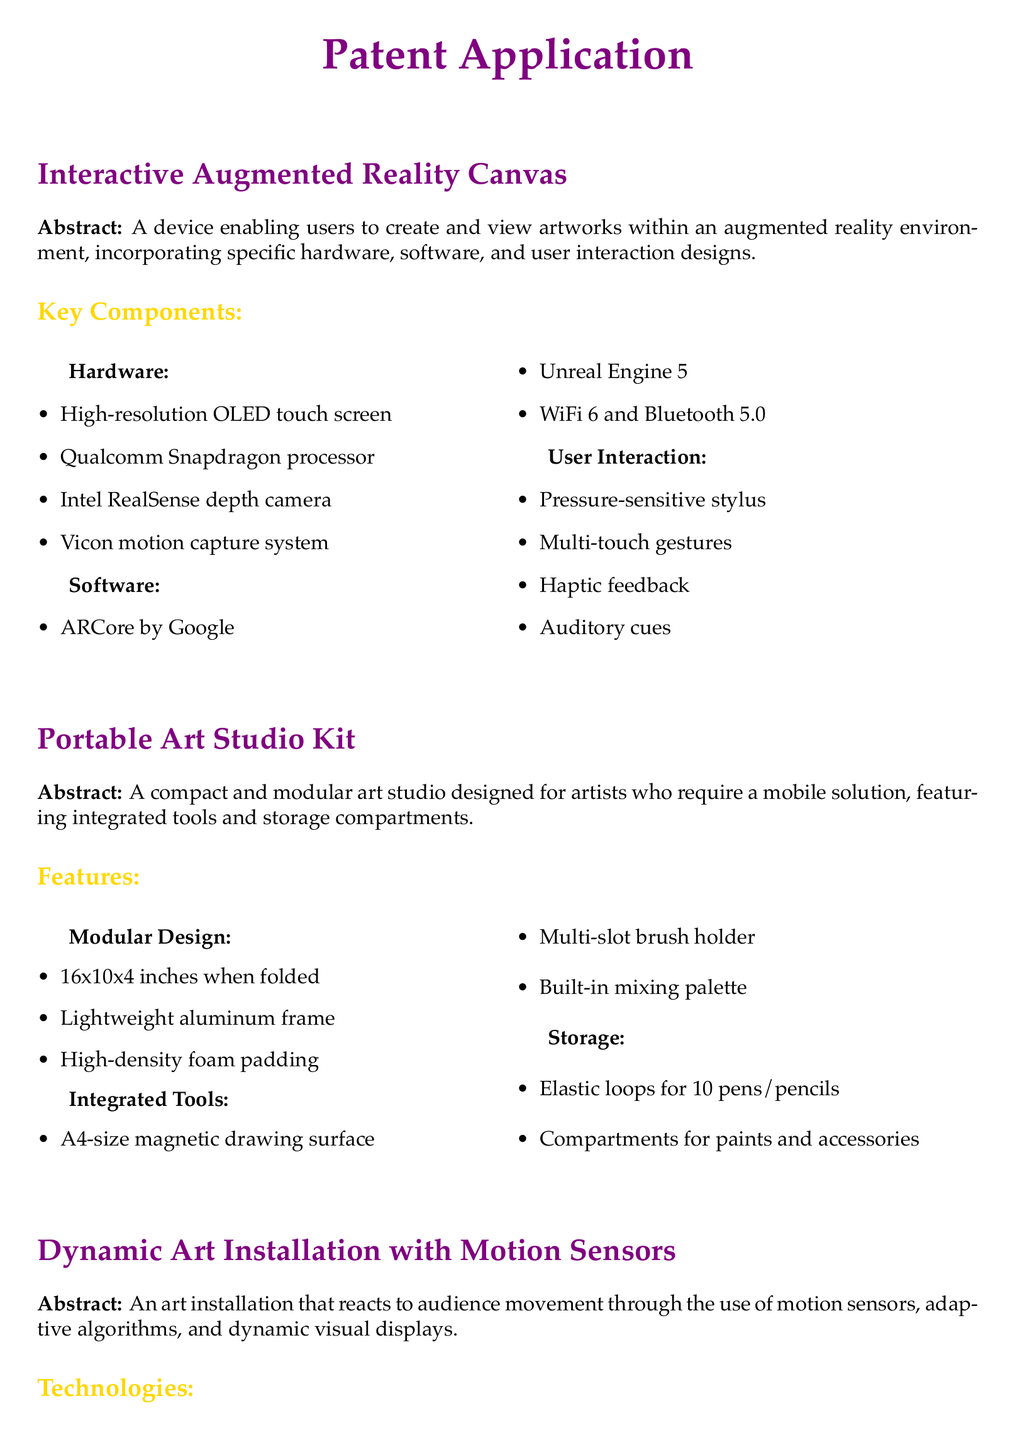What is the size of the portable art studio when folded? The size of the portable art studio is mentioned in the features section, which states it is 16x10x4 inches when folded.
Answer: 16x10x4 inches What type of processor is used in the interactive augmented reality canvas? The hardware section lists the Qualcomm Snapdragon processor as part of the interactive augmented reality canvas.
Answer: Qualcomm Snapdragon What technology is used for color recognition in the smart painting palette? The sensor technology used for color recognition is elaborated in the smart painting palette's features, which includes advanced sensors.
Answer: advanced sensors How does the dynamic art installation change? The abstract mentions that the art installation changes dynamically based on audience movement.
Answer: based on audience movement What is the material of the modular workstation's frame? The modular design section details that the frame is made of lightweight aluminum.
Answer: lightweight aluminum What motion sensor technology is mentioned in the document? The technologies section specifies LIDAR infrared sensor and ultrasonic distance sensor as the motion sensor technologies used.
Answer: LIDAR infrared sensor and ultrasonic distance sensor What feedback features does the interactive augmented reality canvas provide? The user interaction section includes haptic feedback as one of the interaction designs provided by the canvas.
Answer: haptic feedback What is the purpose of the autonomous art conservation robot? The main objective of the autonomous art conservation robot, as outlined in the patent application, is for art conservation tasks.
Answer: art conservation tasks 